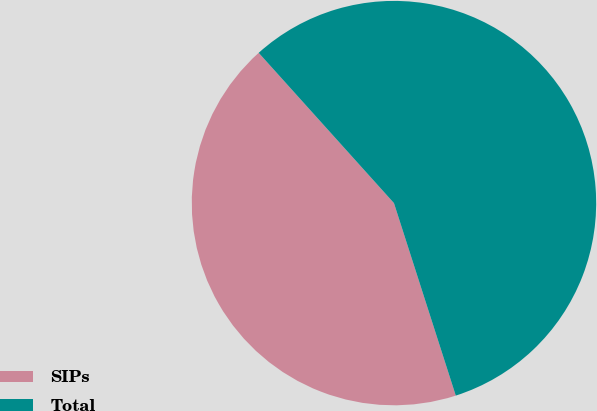Convert chart. <chart><loc_0><loc_0><loc_500><loc_500><pie_chart><fcel>SIPs<fcel>Total<nl><fcel>43.28%<fcel>56.72%<nl></chart> 